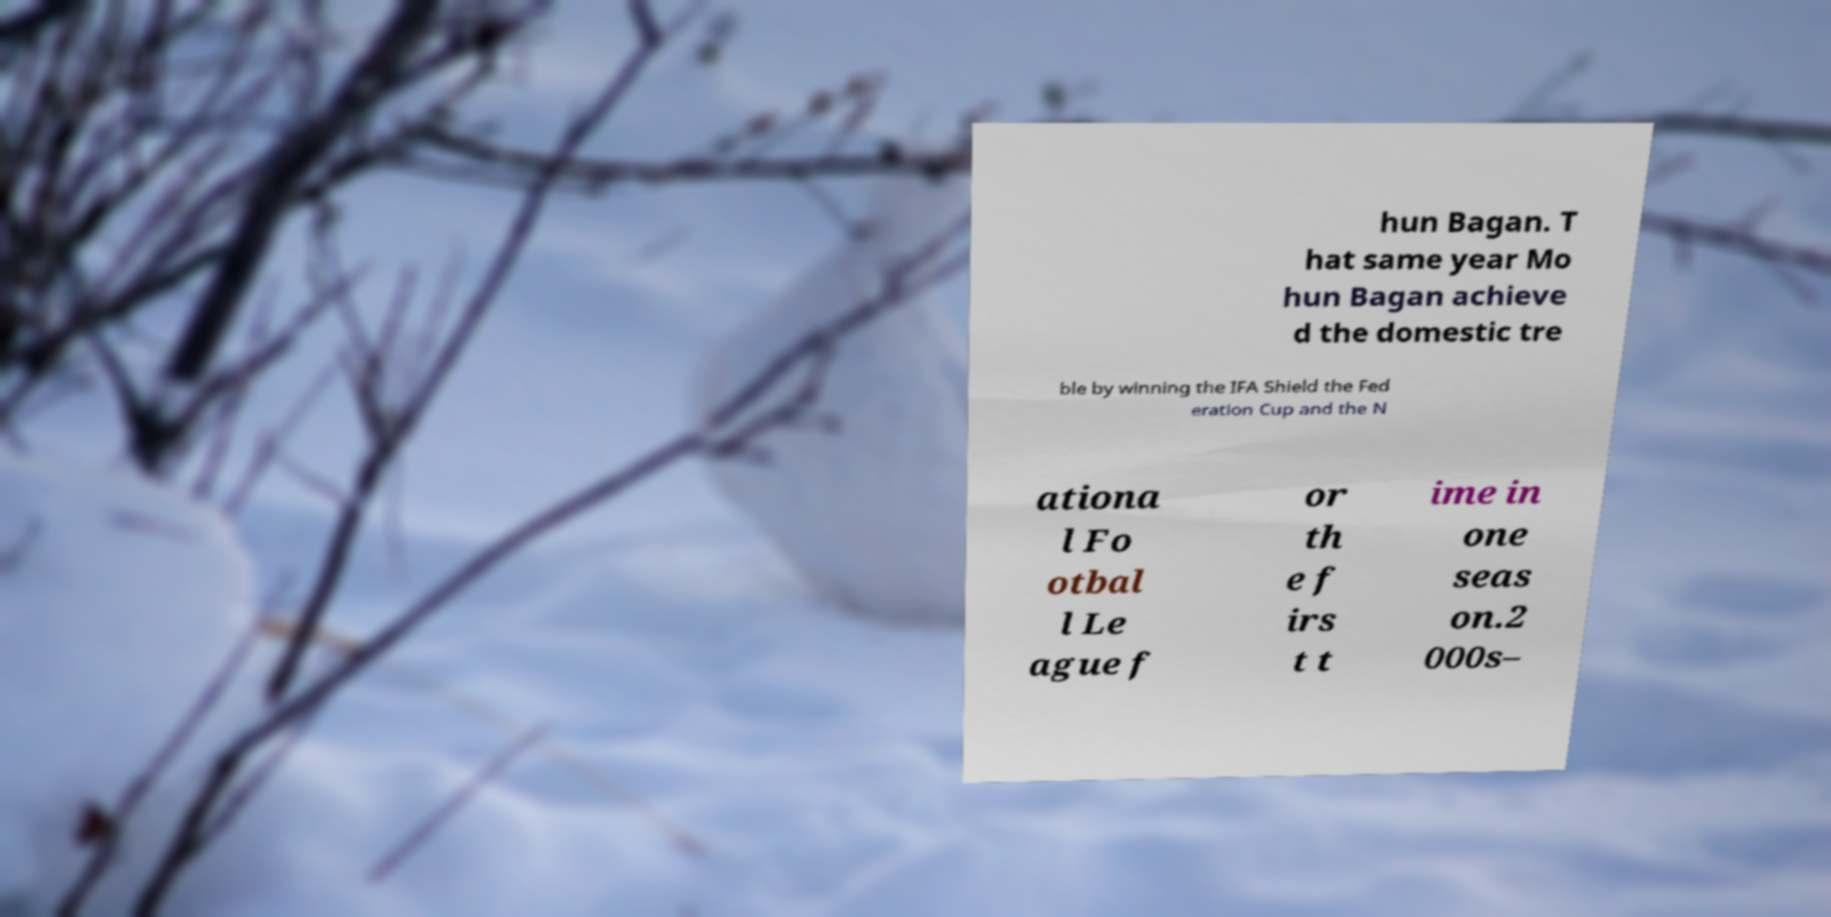I need the written content from this picture converted into text. Can you do that? hun Bagan. T hat same year Mo hun Bagan achieve d the domestic tre ble by winning the IFA Shield the Fed eration Cup and the N ationa l Fo otbal l Le ague f or th e f irs t t ime in one seas on.2 000s– 